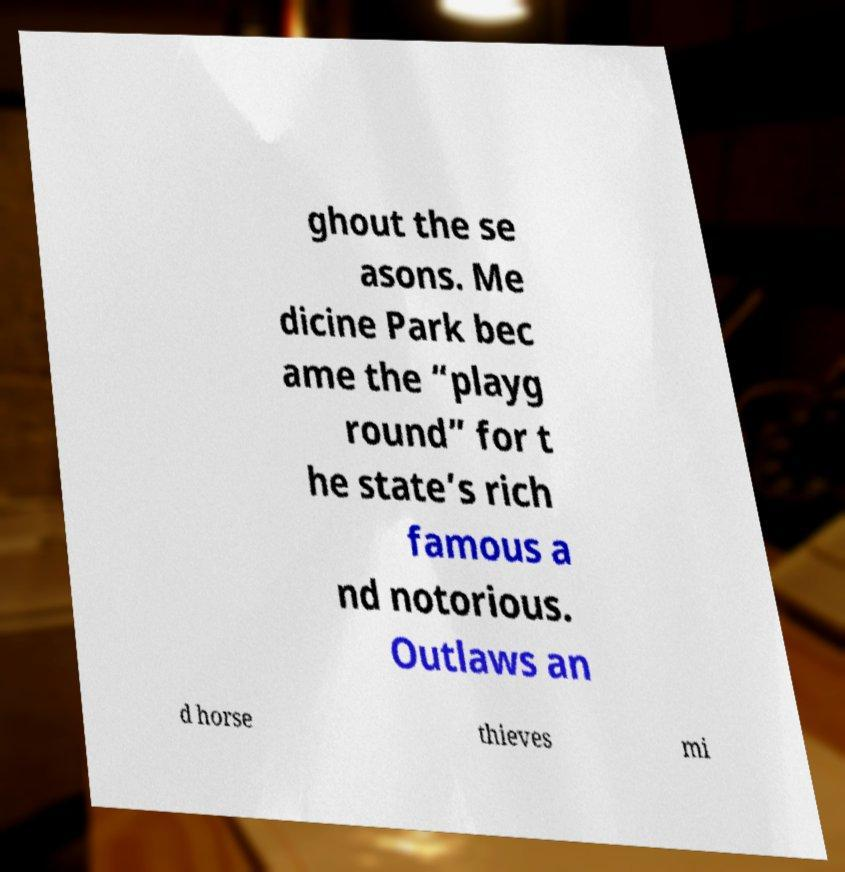For documentation purposes, I need the text within this image transcribed. Could you provide that? ghout the se asons. Me dicine Park bec ame the “playg round” for t he state’s rich famous a nd notorious. Outlaws an d horse thieves mi 